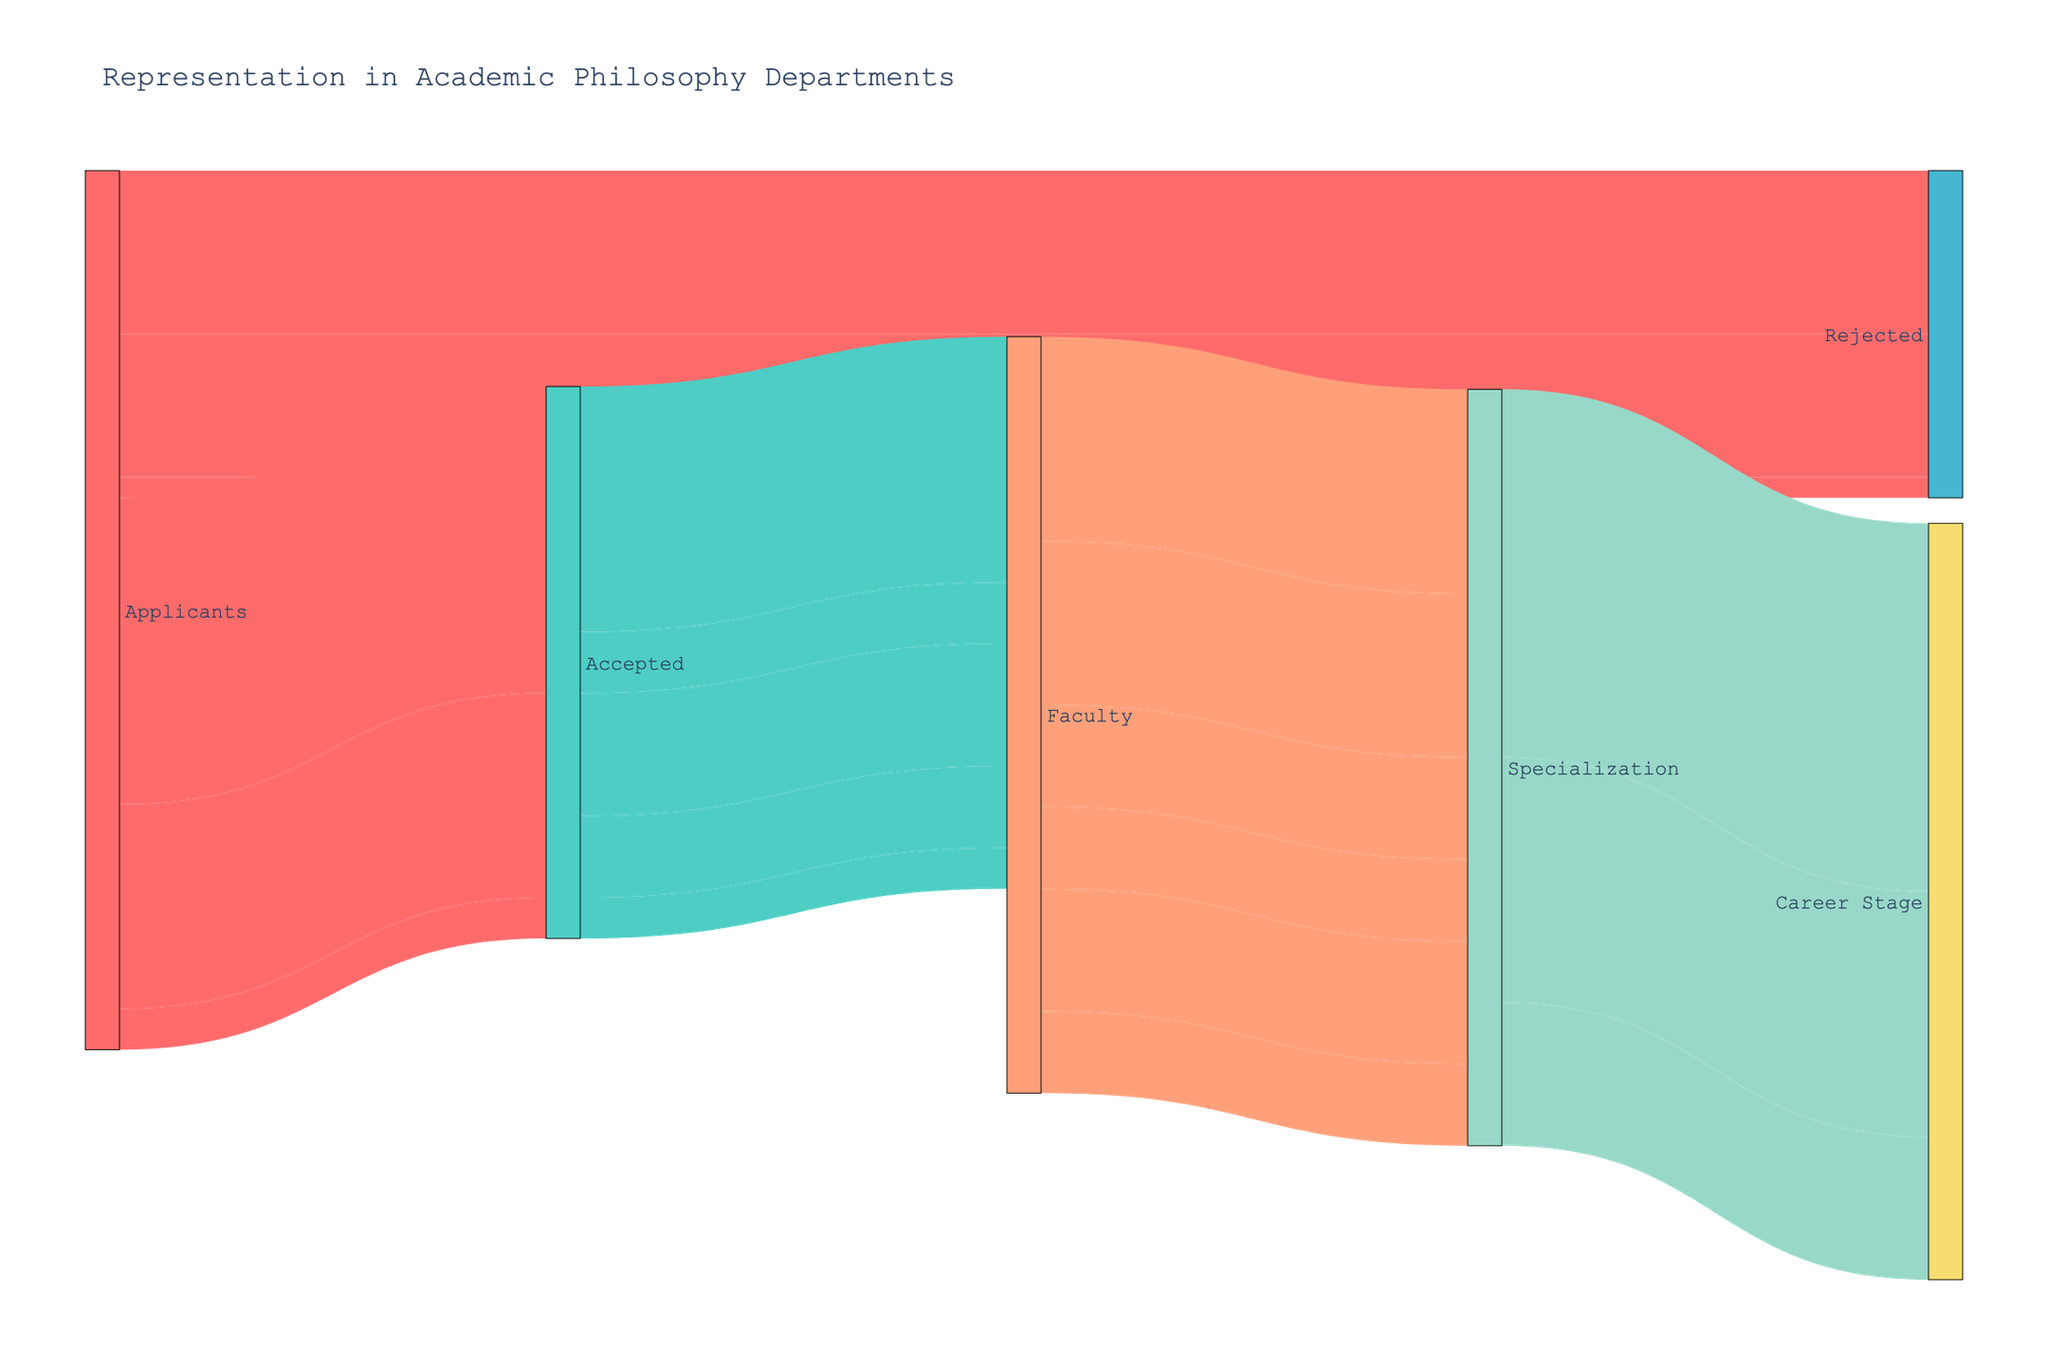What is the title of the figure? The title of the figure is usually placed at the top and it summarizes the main point of the figure. In this case, it’s placed centrally above the diagram.
Answer: Representation in Academic Philosophy Departments How many categories of applicants are shown? Each category of applicants is derived from the boxes on the left side where the flows originate. In this figure, there are three applicant categories.
Answer: 3 What is the total number of accepted applicants? To find the total accepted applicants, sum the applicants who were accepted: 150 (Male) + 100 (Female) + 20 (Non-binary).
Answer: 270 Which gender category has the highest rejection rate? Calculate rejection by comparing the total applicants to those rejected. Males have 150 accepted and 80 rejected, females 100 accepted and 70 rejected, non-binary 20 accepted and 10 rejected. Rejection rates (rejected/total): Male = 80/230, Female = 70/170, Non-binary = 10/30.
Answer: Male How many faculty specialize in both Feminist Philosophy and Philosophy of Race combined? Summing the values specifically from Feminist Philosophy and Philosophy of Race specializations, which are two separate flows converging from faculty: 50 + 40.
Answer: 90 What percentage of the faculty members is tenured? Calculate this by dividing the number of tenured faculty (180) by the total faculty (sum of tenured, tenure-track, and non-tenure track: 180 + 120 + 70) and multiply by 100 to get the percentage.
Answer: 52.94% Who has a higher representation in faculty: applicants accepted who identify as White or Asian? From the segment showing faculty from accepted racial categories, compare the number: White (120) versus Asian (60).
Answer: White What is the difference between the number of faculty in Ethics and Epistemology? Subtract the number of faculty in Epistemology from that in Ethics. Ethics: 60, Epistemology: 40.
Answer: 20 How many faculty members specialize in either Analytic or Continental Philosophy? Sum the values for faculty specializing in Analytic Philosophy (100) and Continental Philosophy (80).
Answer: 180 